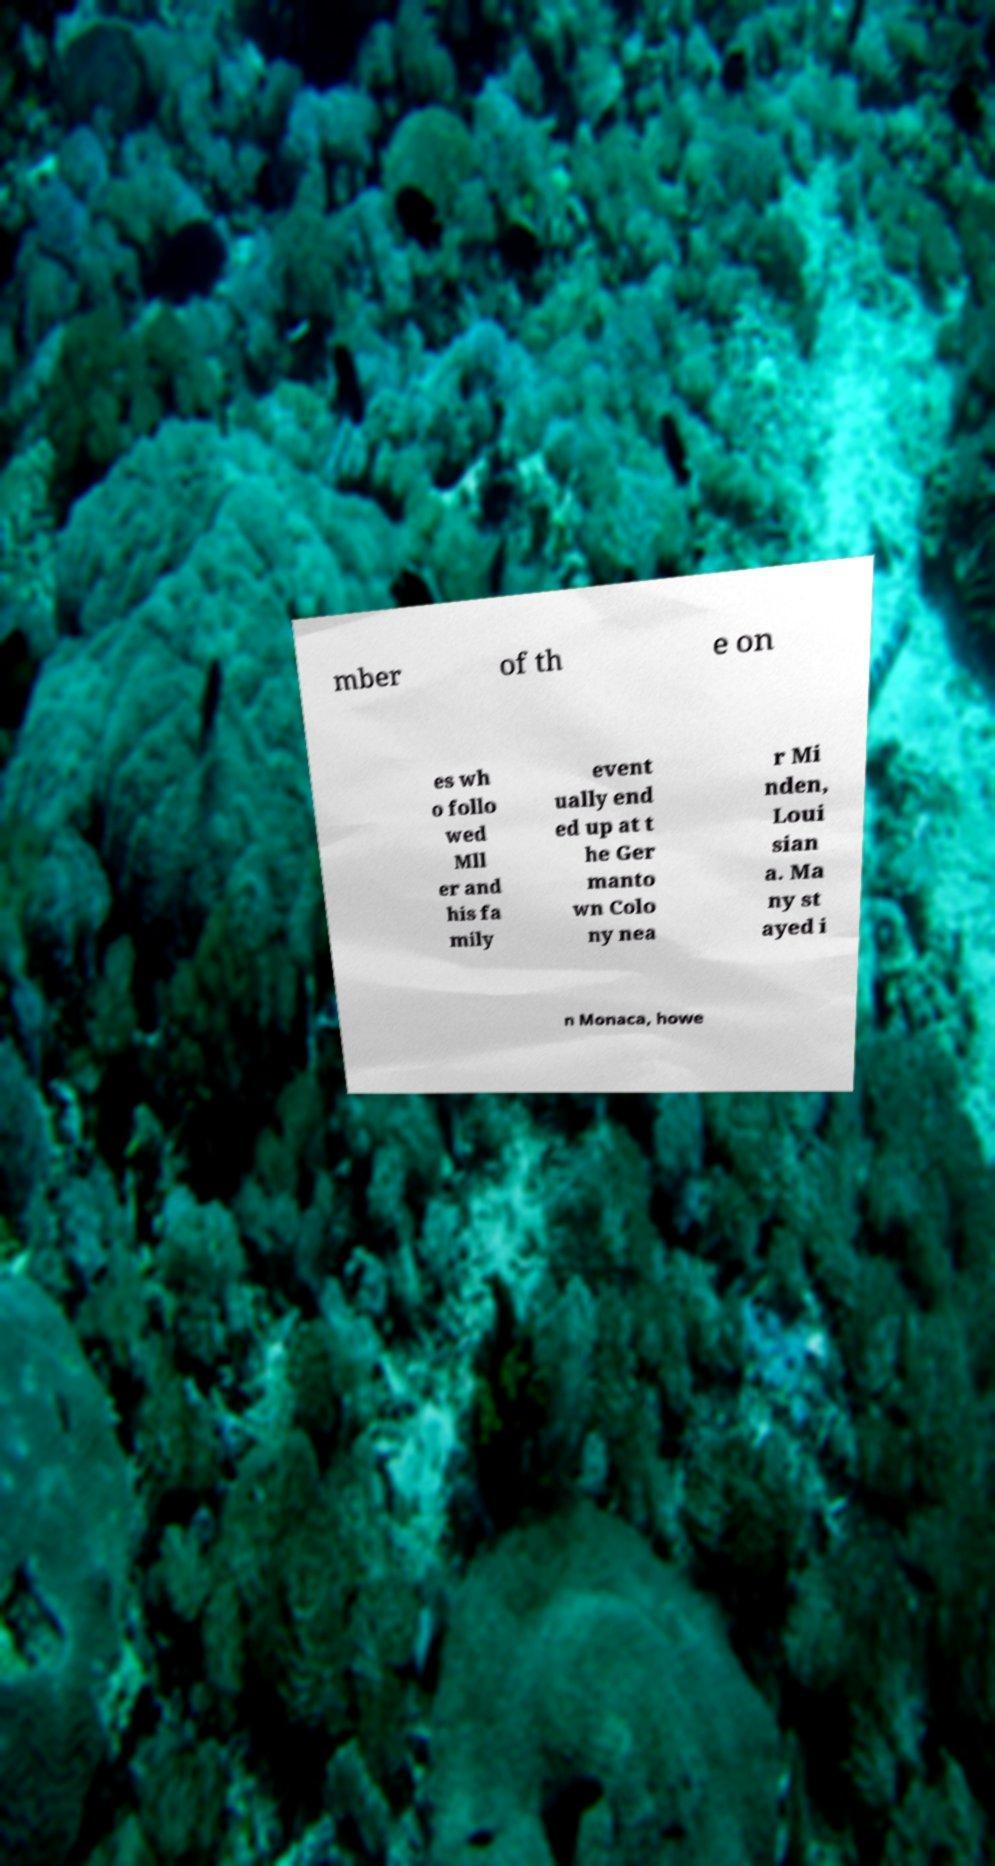Please read and relay the text visible in this image. What does it say? mber of th e on es wh o follo wed Mll er and his fa mily event ually end ed up at t he Ger manto wn Colo ny nea r Mi nden, Loui sian a. Ma ny st ayed i n Monaca, howe 